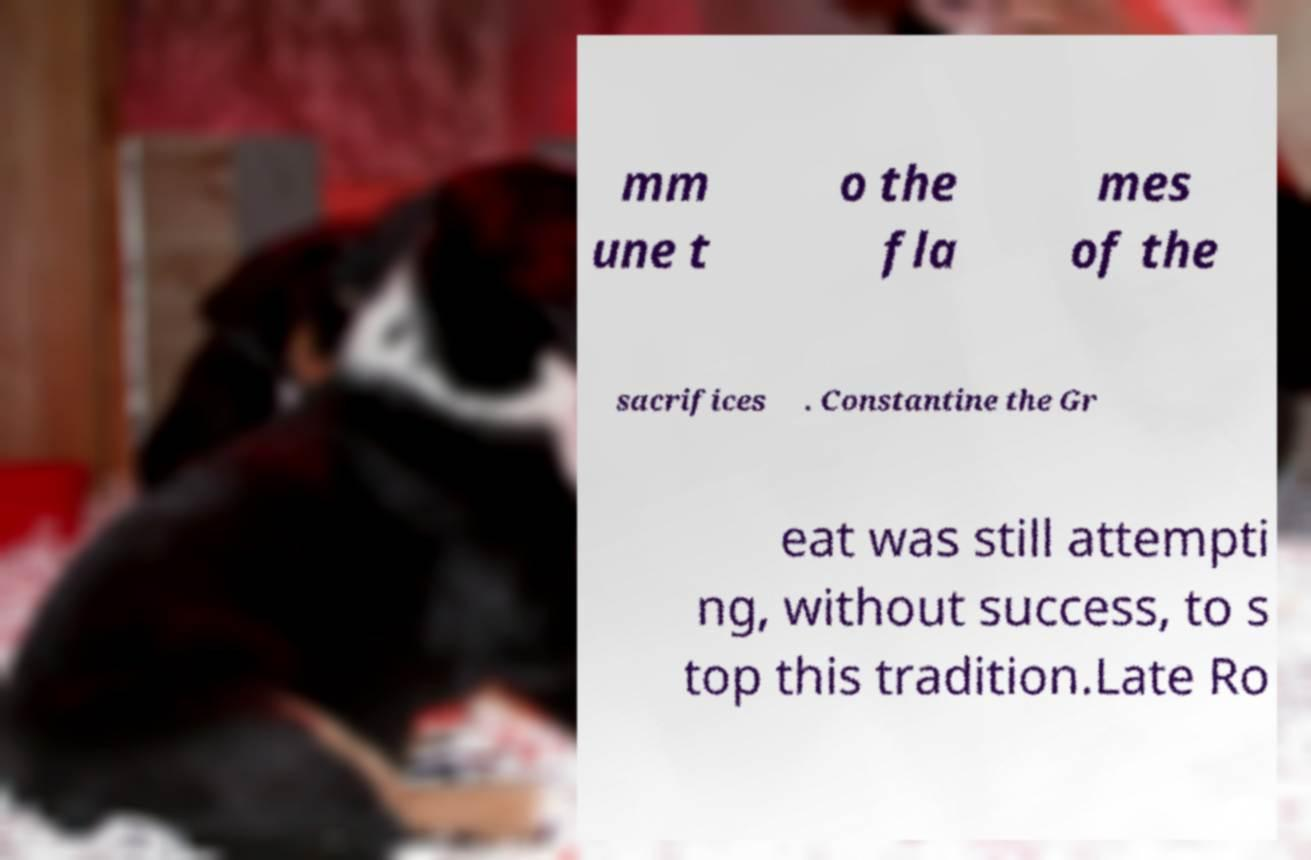Can you read and provide the text displayed in the image?This photo seems to have some interesting text. Can you extract and type it out for me? mm une t o the fla mes of the sacrifices . Constantine the Gr eat was still attempti ng, without success, to s top this tradition.Late Ro 